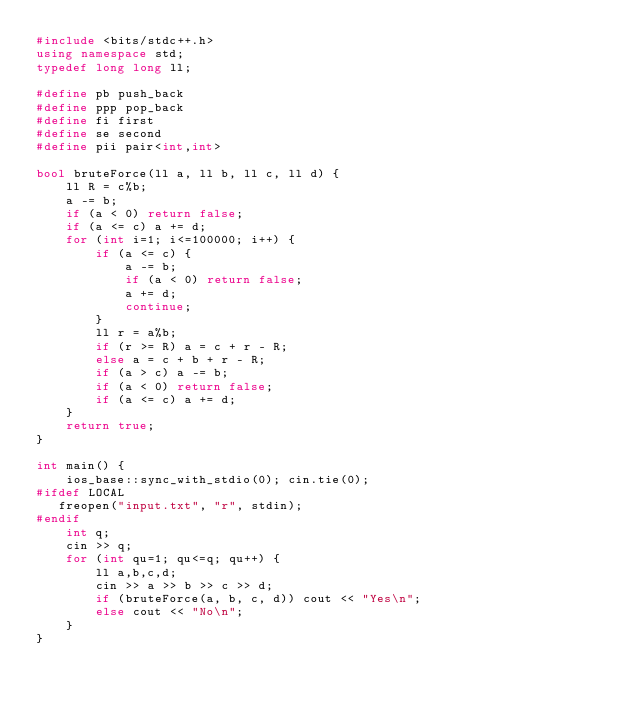Convert code to text. <code><loc_0><loc_0><loc_500><loc_500><_C++_>#include <bits/stdc++.h>
using namespace std;
typedef long long ll;

#define pb push_back
#define ppp pop_back
#define fi first
#define se second
#define pii pair<int,int>

bool bruteForce(ll a, ll b, ll c, ll d) {
    ll R = c%b;
    a -= b;
    if (a < 0) return false;
    if (a <= c) a += d;
    for (int i=1; i<=100000; i++) {
        if (a <= c) {
            a -= b;
            if (a < 0) return false;
            a += d;
            continue;
        }
        ll r = a%b;
        if (r >= R) a = c + r - R;
        else a = c + b + r - R;
        if (a > c) a -= b;
        if (a < 0) return false;
        if (a <= c) a += d;
    }
    return true;
}

int main() {
    ios_base::sync_with_stdio(0); cin.tie(0);
#ifdef LOCAL
   freopen("input.txt", "r", stdin);
#endif
    int q;
    cin >> q;
    for (int qu=1; qu<=q; qu++) {
        ll a,b,c,d;
        cin >> a >> b >> c >> d;
        if (bruteForce(a, b, c, d)) cout << "Yes\n";
        else cout << "No\n";
    }
}
</code> 